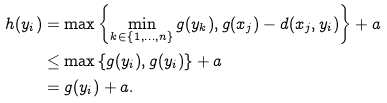Convert formula to latex. <formula><loc_0><loc_0><loc_500><loc_500>h ( y _ { i } ) & = \max \left \{ \min _ { k \in \{ 1 , \dots , n \} } g ( y _ { k } ) , g ( x _ { j } ) - d ( x _ { j } , y _ { i } ) \right \} + a \\ & \leq \max \left \{ g ( y _ { i } ) , g ( y _ { i } ) \right \} + a \\ & = g ( y _ { i } ) + a .</formula> 